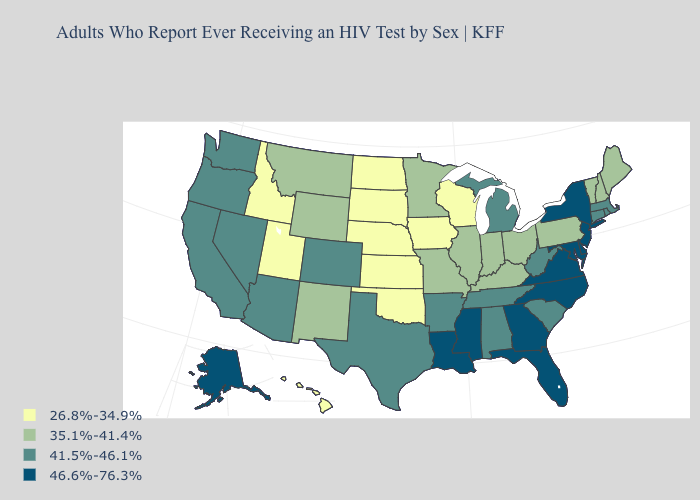What is the value of Washington?
Answer briefly. 41.5%-46.1%. Does the first symbol in the legend represent the smallest category?
Concise answer only. Yes. What is the value of North Dakota?
Quick response, please. 26.8%-34.9%. Does Nevada have the lowest value in the West?
Short answer required. No. Name the states that have a value in the range 35.1%-41.4%?
Short answer required. Illinois, Indiana, Kentucky, Maine, Minnesota, Missouri, Montana, New Hampshire, New Mexico, Ohio, Pennsylvania, Vermont, Wyoming. Does Oklahoma have the lowest value in the USA?
Give a very brief answer. Yes. Does the first symbol in the legend represent the smallest category?
Keep it brief. Yes. Name the states that have a value in the range 46.6%-76.3%?
Concise answer only. Alaska, Delaware, Florida, Georgia, Louisiana, Maryland, Mississippi, New Jersey, New York, North Carolina, Virginia. Does New Hampshire have a lower value than Kentucky?
Concise answer only. No. What is the highest value in states that border Vermont?
Give a very brief answer. 46.6%-76.3%. Among the states that border South Dakota , does Iowa have the lowest value?
Answer briefly. Yes. Does South Dakota have the lowest value in the USA?
Concise answer only. Yes. What is the value of Virginia?
Quick response, please. 46.6%-76.3%. Name the states that have a value in the range 35.1%-41.4%?
Be succinct. Illinois, Indiana, Kentucky, Maine, Minnesota, Missouri, Montana, New Hampshire, New Mexico, Ohio, Pennsylvania, Vermont, Wyoming. Is the legend a continuous bar?
Quick response, please. No. 